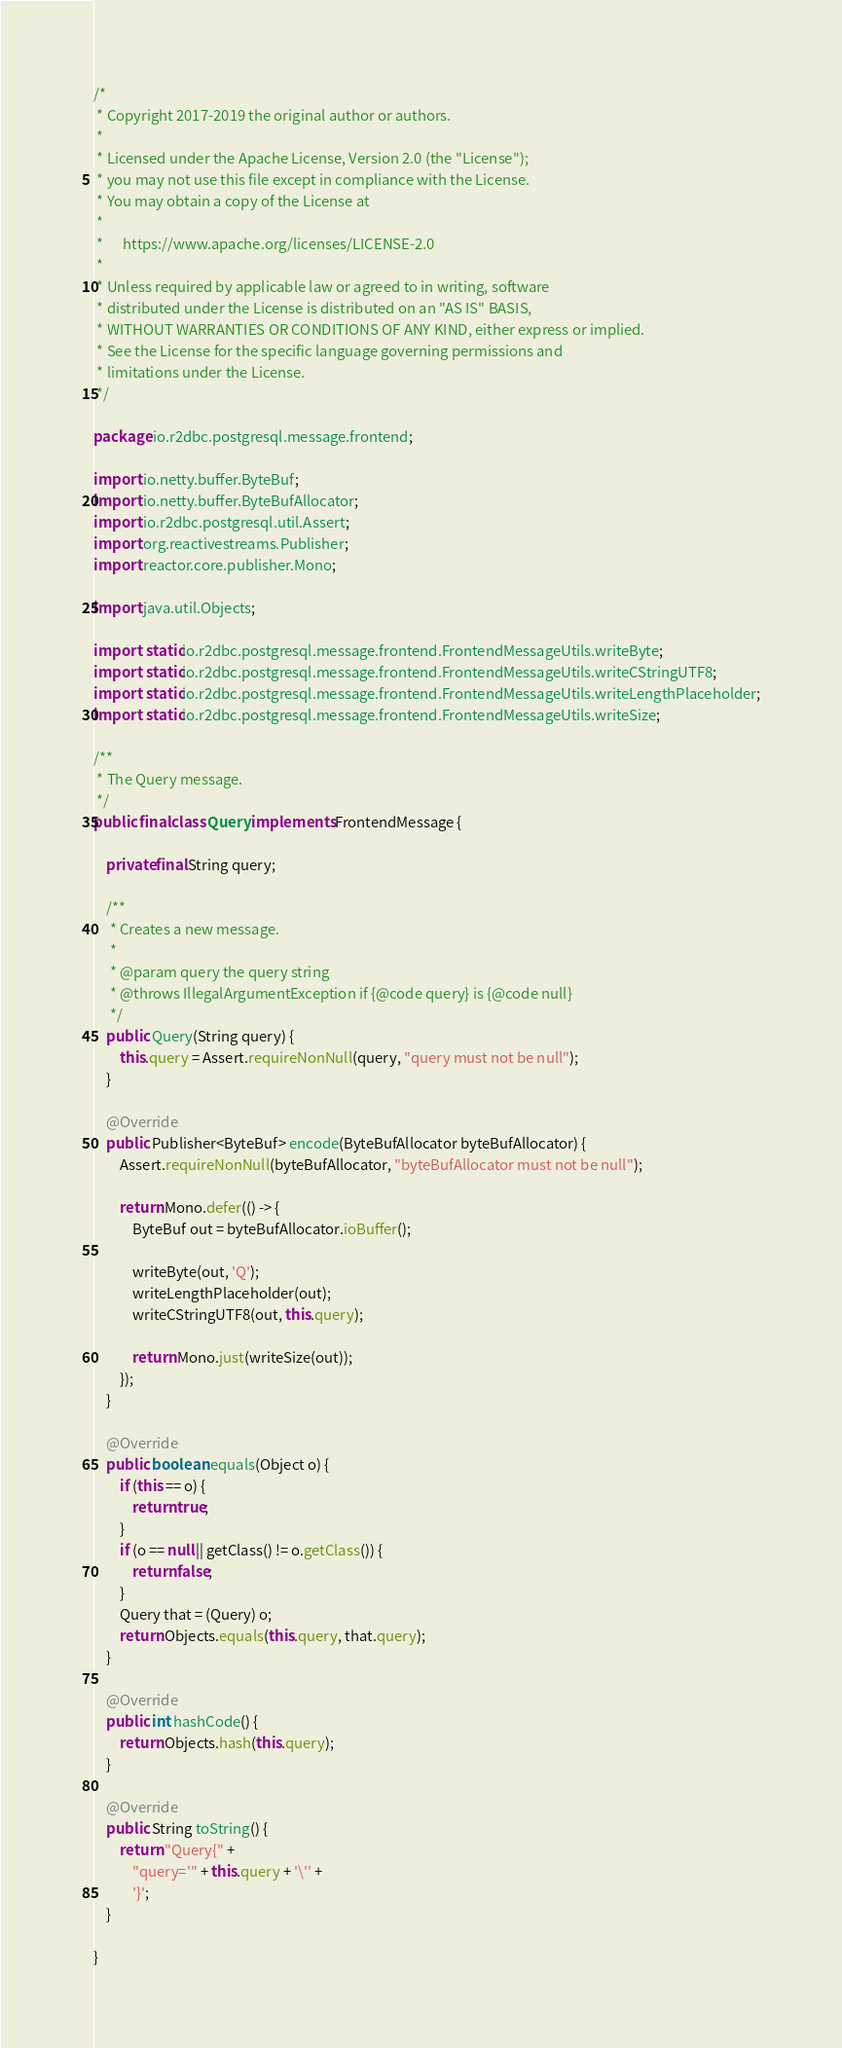Convert code to text. <code><loc_0><loc_0><loc_500><loc_500><_Java_>/*
 * Copyright 2017-2019 the original author or authors.
 *
 * Licensed under the Apache License, Version 2.0 (the "License");
 * you may not use this file except in compliance with the License.
 * You may obtain a copy of the License at
 *
 *      https://www.apache.org/licenses/LICENSE-2.0
 *
 * Unless required by applicable law or agreed to in writing, software
 * distributed under the License is distributed on an "AS IS" BASIS,
 * WITHOUT WARRANTIES OR CONDITIONS OF ANY KIND, either express or implied.
 * See the License for the specific language governing permissions and
 * limitations under the License.
 */

package io.r2dbc.postgresql.message.frontend;

import io.netty.buffer.ByteBuf;
import io.netty.buffer.ByteBufAllocator;
import io.r2dbc.postgresql.util.Assert;
import org.reactivestreams.Publisher;
import reactor.core.publisher.Mono;

import java.util.Objects;

import static io.r2dbc.postgresql.message.frontend.FrontendMessageUtils.writeByte;
import static io.r2dbc.postgresql.message.frontend.FrontendMessageUtils.writeCStringUTF8;
import static io.r2dbc.postgresql.message.frontend.FrontendMessageUtils.writeLengthPlaceholder;
import static io.r2dbc.postgresql.message.frontend.FrontendMessageUtils.writeSize;

/**
 * The Query message.
 */
public final class Query implements FrontendMessage {

    private final String query;

    /**
     * Creates a new message.
     *
     * @param query the query string
     * @throws IllegalArgumentException if {@code query} is {@code null}
     */
    public Query(String query) {
        this.query = Assert.requireNonNull(query, "query must not be null");
    }

    @Override
    public Publisher<ByteBuf> encode(ByteBufAllocator byteBufAllocator) {
        Assert.requireNonNull(byteBufAllocator, "byteBufAllocator must not be null");

        return Mono.defer(() -> {
            ByteBuf out = byteBufAllocator.ioBuffer();

            writeByte(out, 'Q');
            writeLengthPlaceholder(out);
            writeCStringUTF8(out, this.query);

            return Mono.just(writeSize(out));
        });
    }

    @Override
    public boolean equals(Object o) {
        if (this == o) {
            return true;
        }
        if (o == null || getClass() != o.getClass()) {
            return false;
        }
        Query that = (Query) o;
        return Objects.equals(this.query, that.query);
    }

    @Override
    public int hashCode() {
        return Objects.hash(this.query);
    }

    @Override
    public String toString() {
        return "Query{" +
            "query='" + this.query + '\'' +
            '}';
    }

}
</code> 